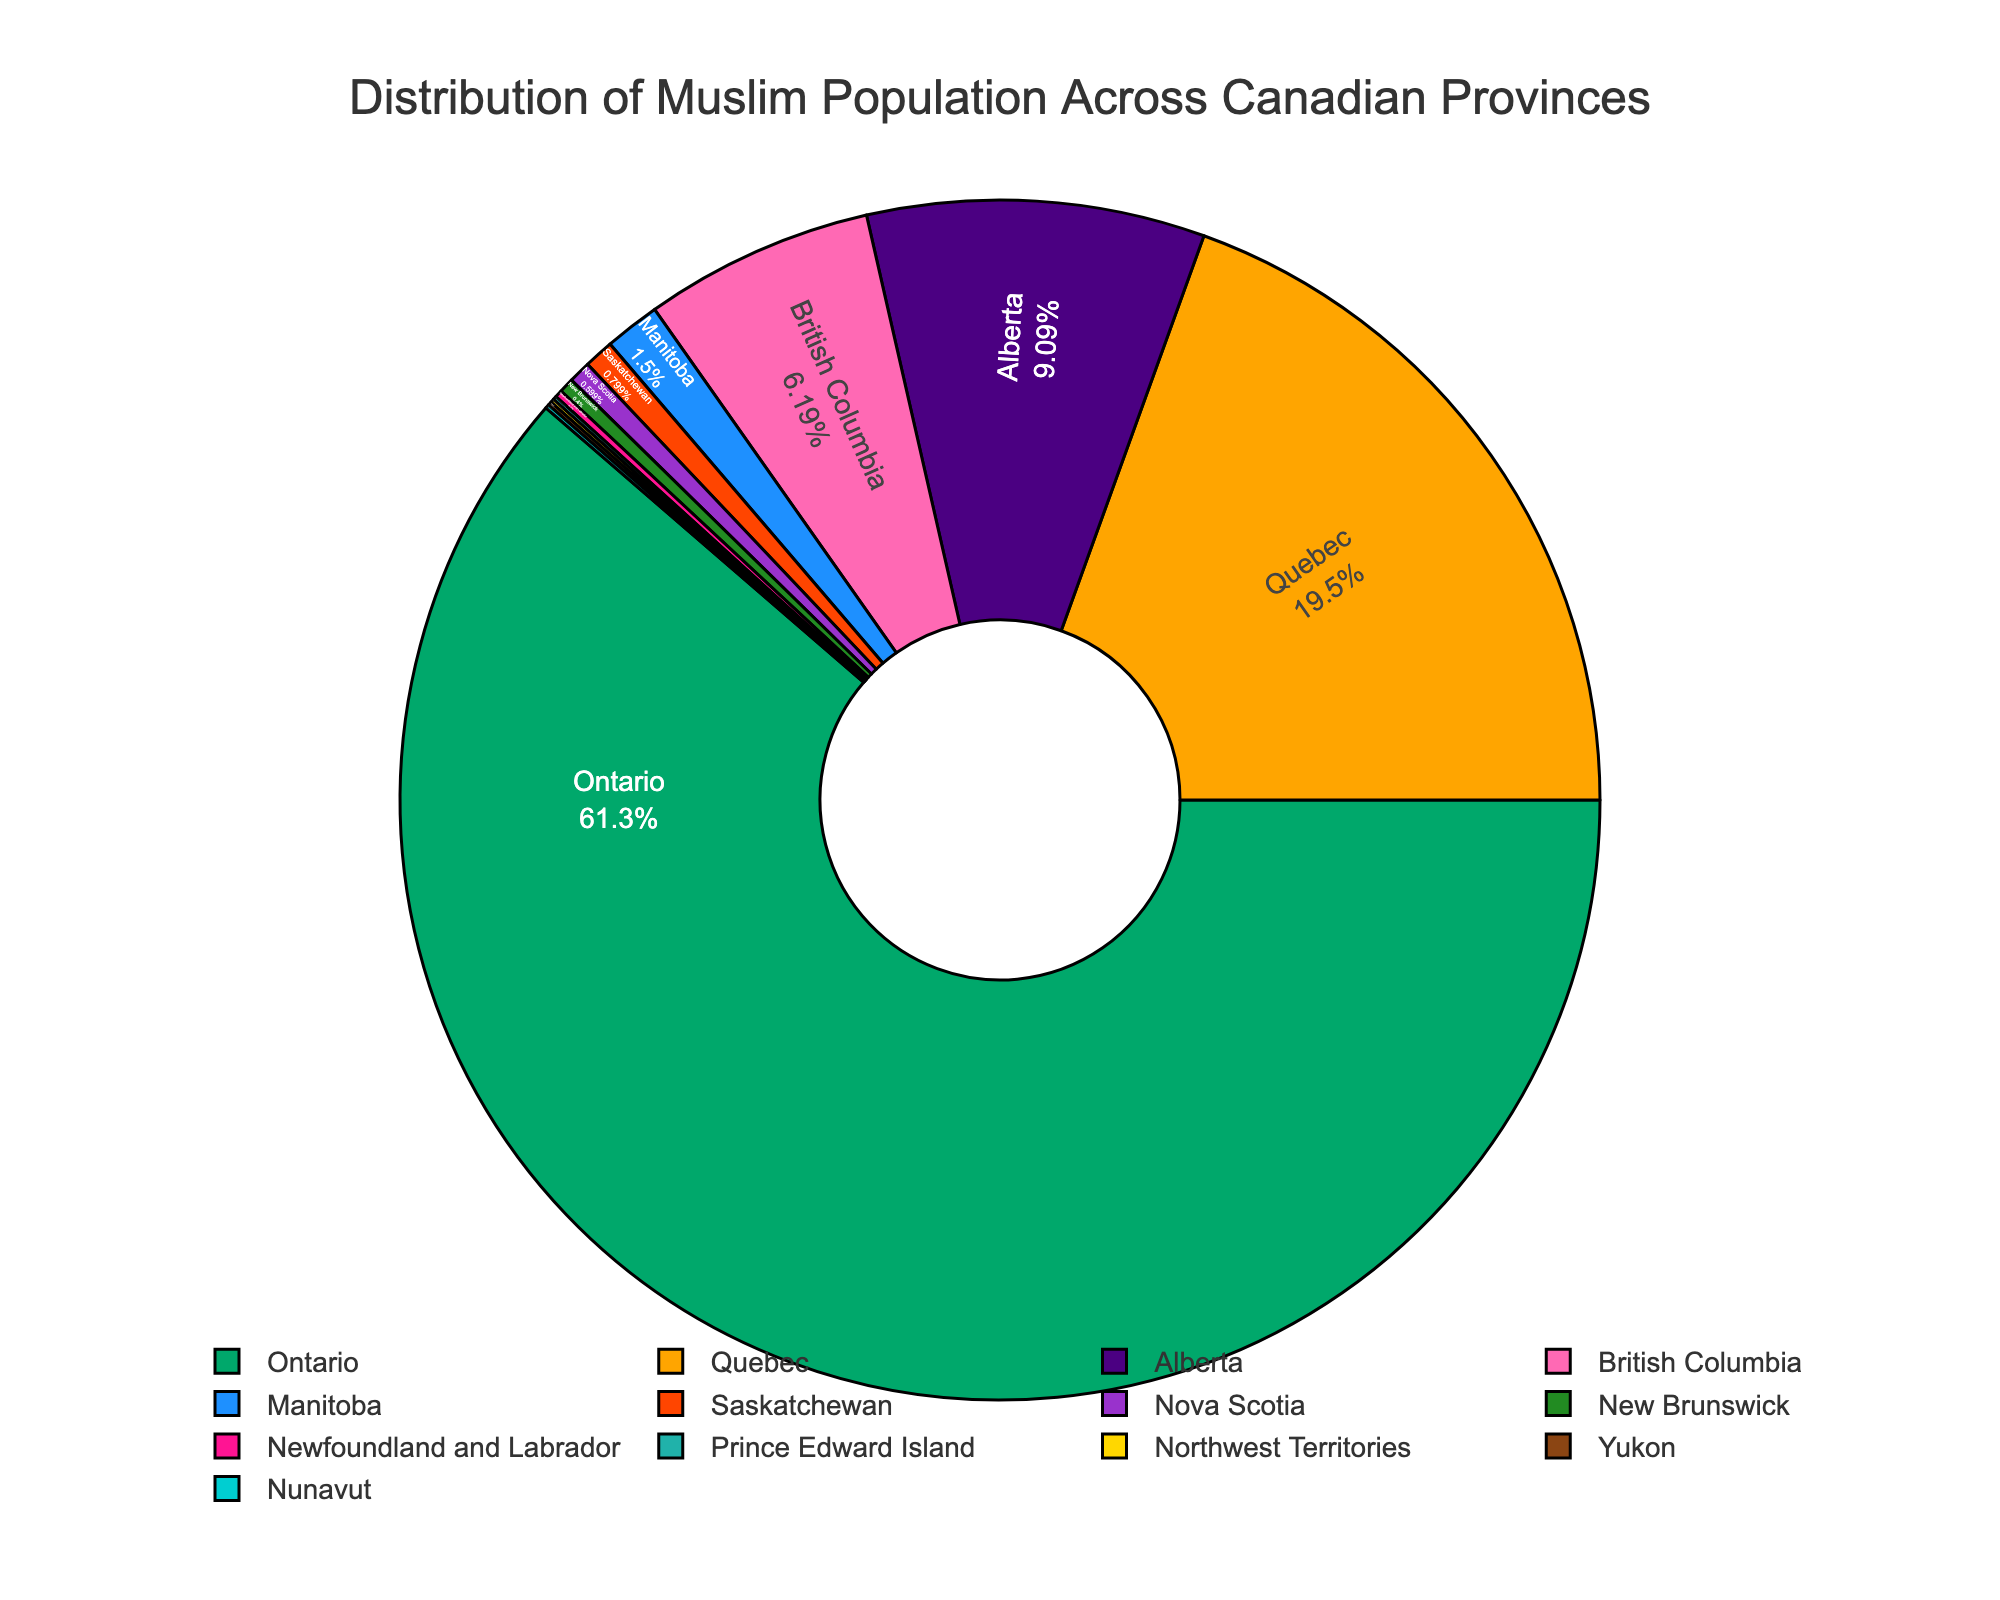which province has the highest Muslim population percentage? To find the highest Muslim population percentage, look at the slice that represents the largest proportion of the pie chart. This slice corresponds to Ontario with 61.4%.
Answer: Ontario how much greater is Ontario's Muslim population percentage compared to Quebec's? Ontario has 61.4% and Quebec has 19.5%. Subtract Quebec's percentage from Ontario's: 61.4% - 19.5% = 41.9%.
Answer: 41.9 which provinces have less than 1% Muslim population? Look for slices that have percentages less than 1%. These are Saskatchewan (0.8%), Nova Scotia (0.6%), New Brunswick (0.4%), Newfoundland and Labrador (0.2%), Prince Edward Island (0.1%), Northwest Territories (0.1%), Yukon (0.1%), and Nunavut (0.1%).
Answer: Saskatchewan, Nova Scotia, New Brunswick, Newfoundland and Labrador, Prince Edward Island, Northwest Territories, Yukon, Nunavut what is the combined Muslim population percentage of Alberta and British Columbia? Sum the percentages of Alberta (9.1%) and British Columbia (6.2%): 9.1% + 6.2% = 15.3%.
Answer: 15.3 which provinces are represented with the smallest percentage segments, and what is the cumulative percentage of these segments? The smallest segments are Prince Edward Island (0.1%), Northwest Territories (0.1%), Yukon (0.1%), and Nunavut (0.1%). Sum these smallest percentages: 0.1% + 0.1% + 0.1% + 0.1% = 0.4%.
Answer: Prince Edward Island, Northwest Territories, Yukon, Nunavut; 0.4 what visual color represents Alberta in the pie chart? Identify the segment with the label "Alberta" and check its color. In the given color scheme, Alberta is denoted by a specific color, which is light blue.
Answer: light blue which provinces have a Muslim population percentage between Manitoba's and Alberta's percentages? Manitoba has 1.5% and Alberta has 9.1%. The provinces between these percentages are British Columbia (6.2%) and Quebec (19.5%).
Answer: British Columbia, Quebec what are the top three provinces in terms of Muslim population percentage? Identify the three largest segments in the pie chart. These are Ontario (61.4%), Quebec (19.5%), and Alberta (9.1%).
Answer: Ontario, Quebec, Alberta how many provinces have a Muslim population percentage less than 2%? Count the segments with percentages less than 2%. These are Manitoba (1.5%), Saskatchewan (0.8%), Nova Scotia (0.6%), New Brunswick (0.4%), Newfoundland and Labrador (0.2%), Prince Edward Island (0.1%), Northwest Territories (0.1%), Yukon (0.1%), and Nunavut (0.1%). This totals 9 provinces.
Answer: 9 